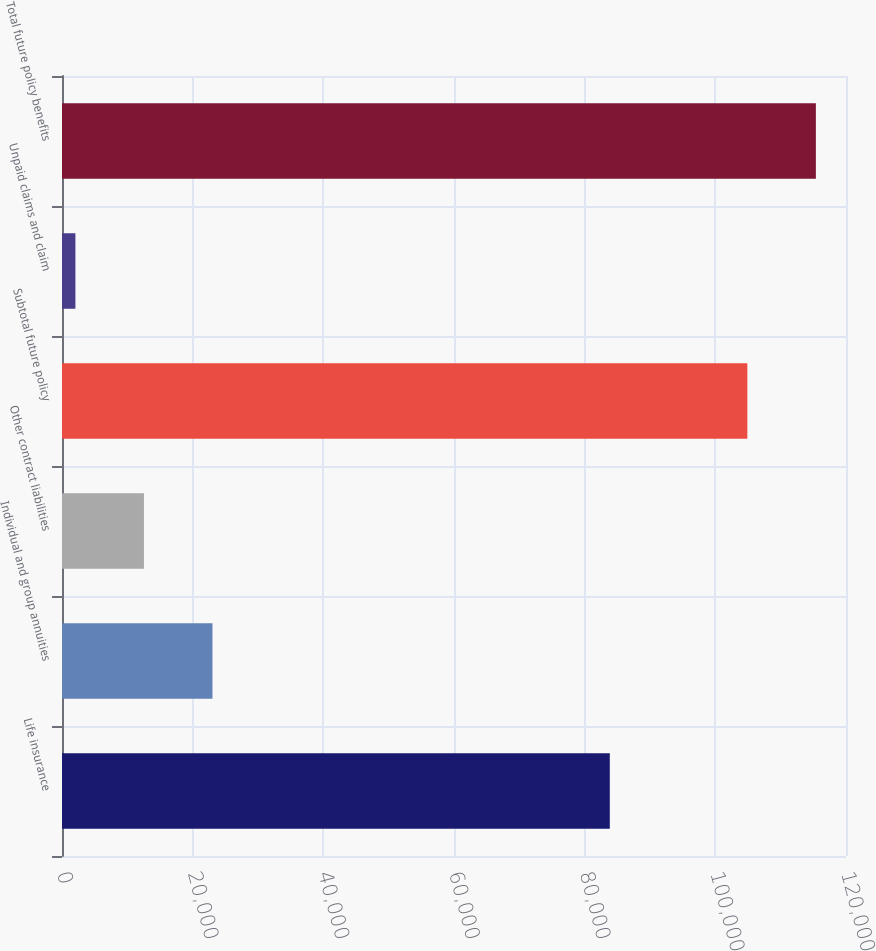<chart> <loc_0><loc_0><loc_500><loc_500><bar_chart><fcel>Life insurance<fcel>Individual and group annuities<fcel>Other contract liabilities<fcel>Subtotal future policy<fcel>Unpaid claims and claim<fcel>Total future policy benefits<nl><fcel>83847<fcel>23031<fcel>12541<fcel>104900<fcel>2051<fcel>115390<nl></chart> 